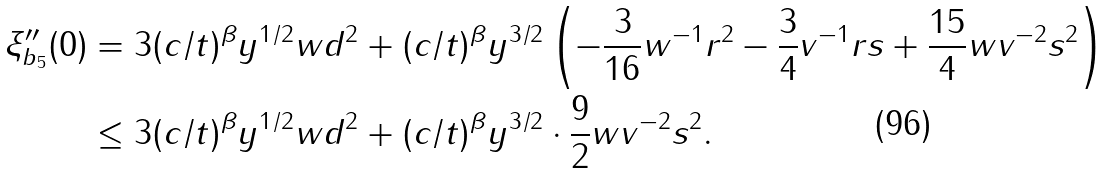<formula> <loc_0><loc_0><loc_500><loc_500>\xi _ { b _ { 5 } } ^ { \prime \prime } ( 0 ) & = 3 ( c / t ) ^ { \beta } y ^ { 1 / 2 } w d ^ { 2 } + ( c / t ) ^ { \beta } y ^ { 3 / 2 } \left ( - \frac { 3 } { 1 6 } w ^ { - 1 } r ^ { 2 } - \frac { 3 } { 4 } v ^ { - 1 } r s + \frac { 1 5 } { 4 } w v ^ { - 2 } s ^ { 2 } \right ) \\ & \leq 3 ( c / t ) ^ { \beta } y ^ { 1 / 2 } w d ^ { 2 } + ( c / t ) ^ { \beta } y ^ { 3 / 2 } \cdot \frac { 9 } { 2 } w v ^ { - 2 } s ^ { 2 } .</formula> 